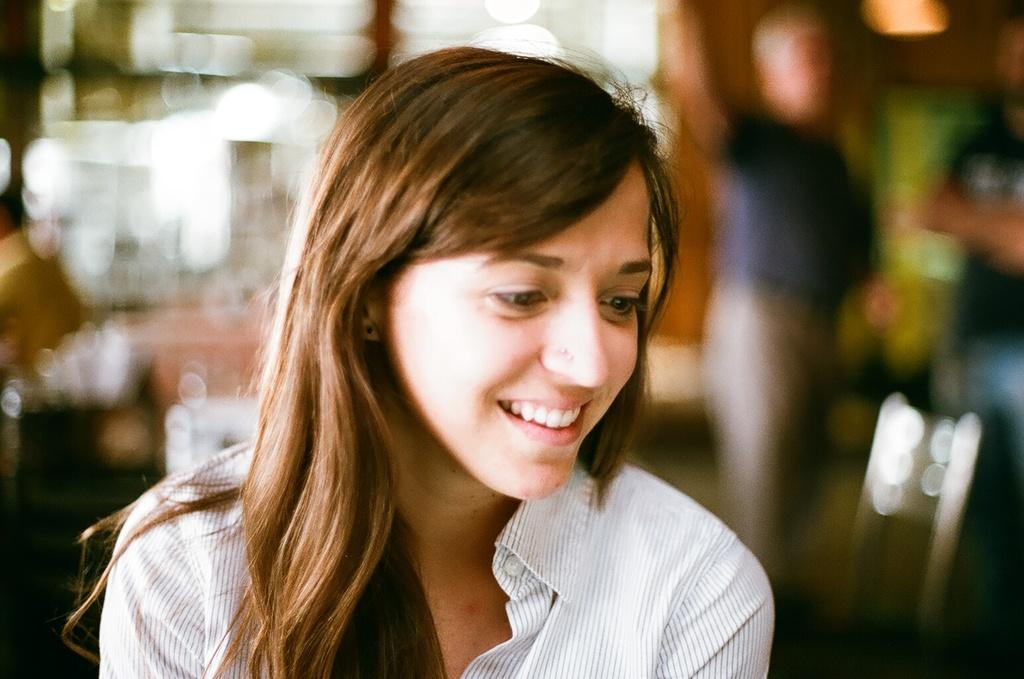Who is the main subject in the image? There is a girl in the image. What is the girl's expression in the image? The girl is smiling in the image. Can you describe the background of the image? The background of the image is blurred. What type of leather can be seen in the image? There is no leather present in the image. What is the shape of the moon in the image? There is no moon present in the image. 